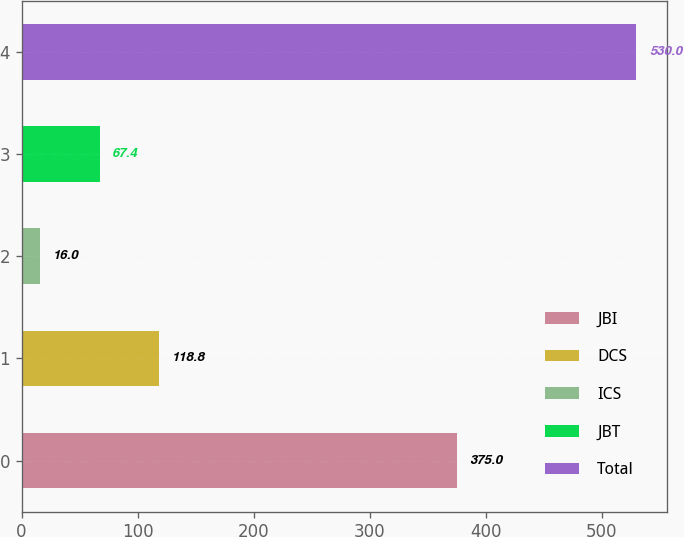Convert chart. <chart><loc_0><loc_0><loc_500><loc_500><bar_chart><fcel>JBI<fcel>DCS<fcel>ICS<fcel>JBT<fcel>Total<nl><fcel>375<fcel>118.8<fcel>16<fcel>67.4<fcel>530<nl></chart> 